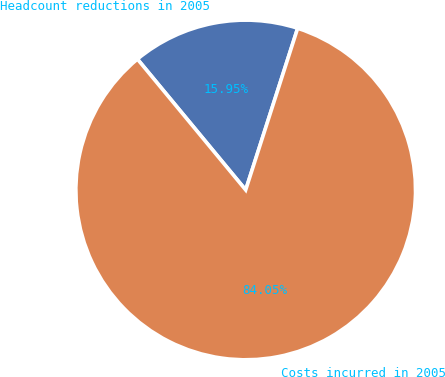Convert chart to OTSL. <chart><loc_0><loc_0><loc_500><loc_500><pie_chart><fcel>Headcount reductions in 2005<fcel>Costs incurred in 2005<nl><fcel>15.95%<fcel>84.05%<nl></chart> 